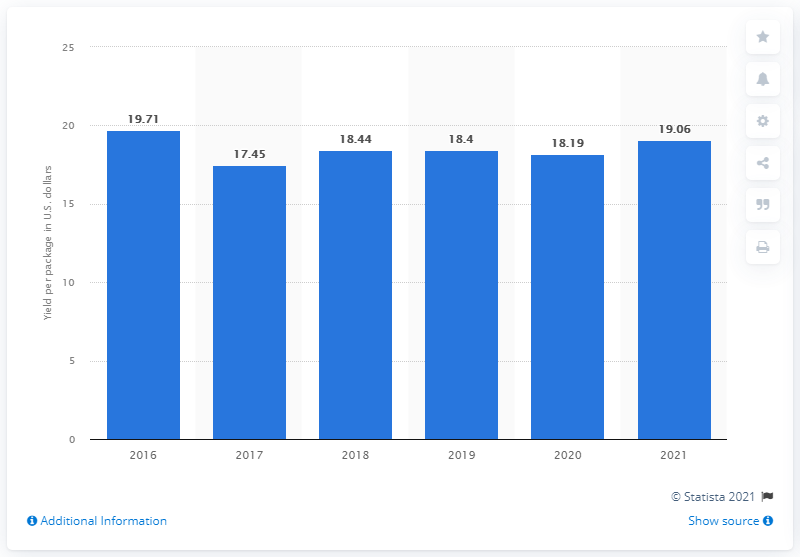List a handful of essential elements in this visual. The package yield of FedEx Express segment of FedEx Corporation in 2021 was 19.06%. 